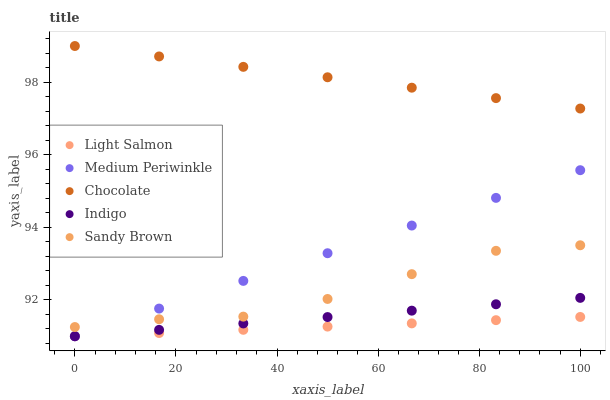Does Light Salmon have the minimum area under the curve?
Answer yes or no. Yes. Does Chocolate have the maximum area under the curve?
Answer yes or no. Yes. Does Medium Periwinkle have the minimum area under the curve?
Answer yes or no. No. Does Medium Periwinkle have the maximum area under the curve?
Answer yes or no. No. Is Light Salmon the smoothest?
Answer yes or no. Yes. Is Sandy Brown the roughest?
Answer yes or no. Yes. Is Medium Periwinkle the smoothest?
Answer yes or no. No. Is Medium Periwinkle the roughest?
Answer yes or no. No. Does Indigo have the lowest value?
Answer yes or no. Yes. Does Sandy Brown have the lowest value?
Answer yes or no. No. Does Chocolate have the highest value?
Answer yes or no. Yes. Does Medium Periwinkle have the highest value?
Answer yes or no. No. Is Indigo less than Sandy Brown?
Answer yes or no. Yes. Is Chocolate greater than Indigo?
Answer yes or no. Yes. Does Light Salmon intersect Indigo?
Answer yes or no. Yes. Is Light Salmon less than Indigo?
Answer yes or no. No. Is Light Salmon greater than Indigo?
Answer yes or no. No. Does Indigo intersect Sandy Brown?
Answer yes or no. No. 